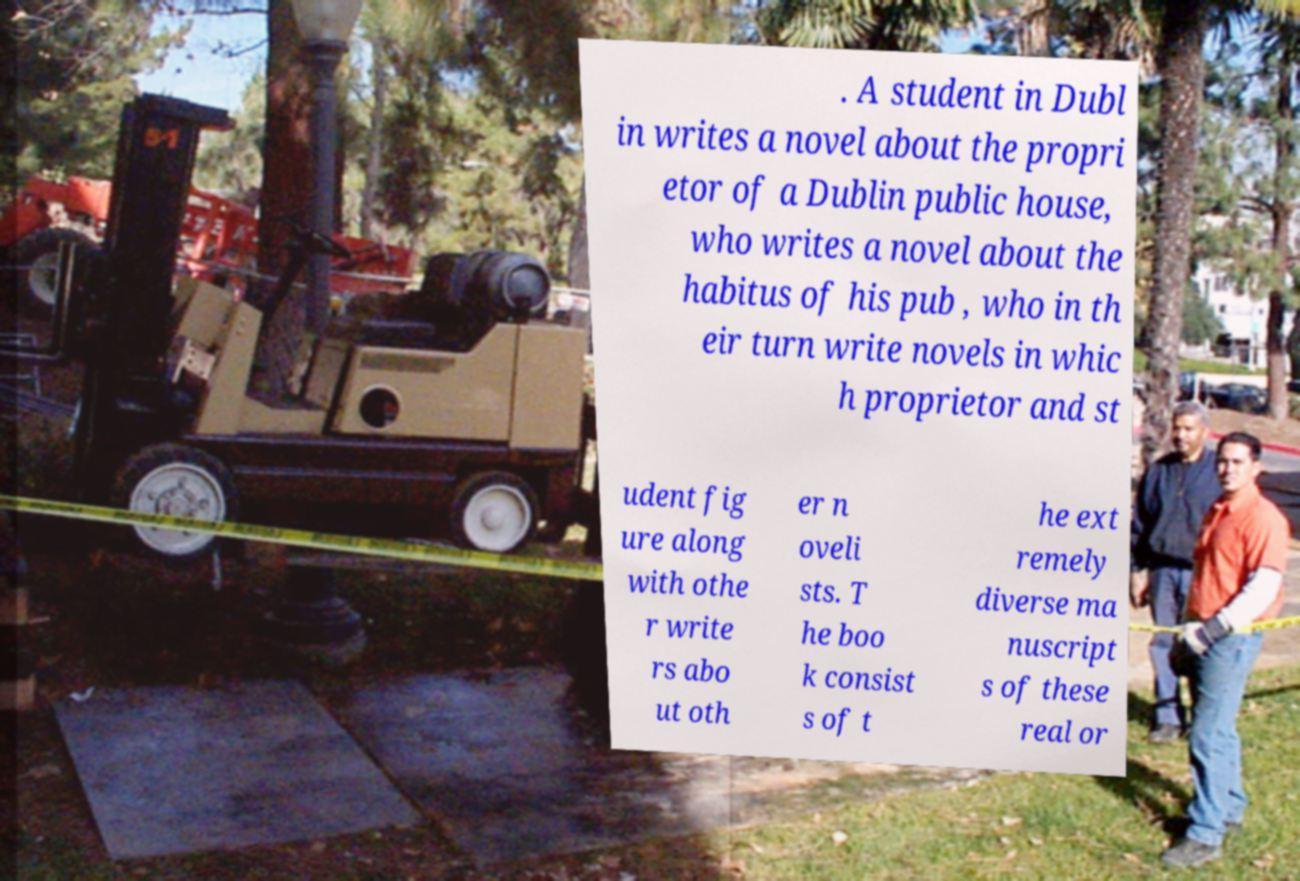I need the written content from this picture converted into text. Can you do that? . A student in Dubl in writes a novel about the propri etor of a Dublin public house, who writes a novel about the habitus of his pub , who in th eir turn write novels in whic h proprietor and st udent fig ure along with othe r write rs abo ut oth er n oveli sts. T he boo k consist s of t he ext remely diverse ma nuscript s of these real or 